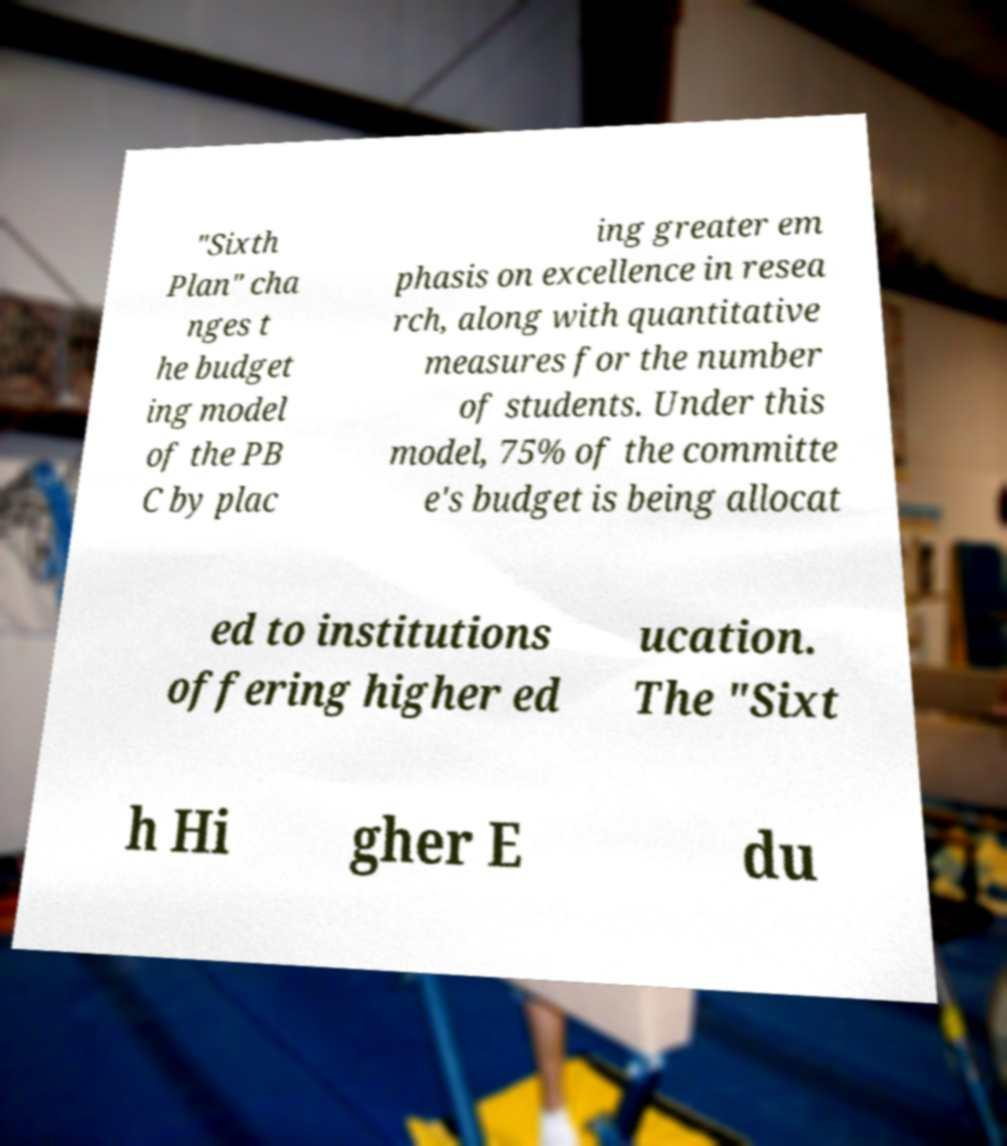There's text embedded in this image that I need extracted. Can you transcribe it verbatim? "Sixth Plan" cha nges t he budget ing model of the PB C by plac ing greater em phasis on excellence in resea rch, along with quantitative measures for the number of students. Under this model, 75% of the committe e's budget is being allocat ed to institutions offering higher ed ucation. The "Sixt h Hi gher E du 